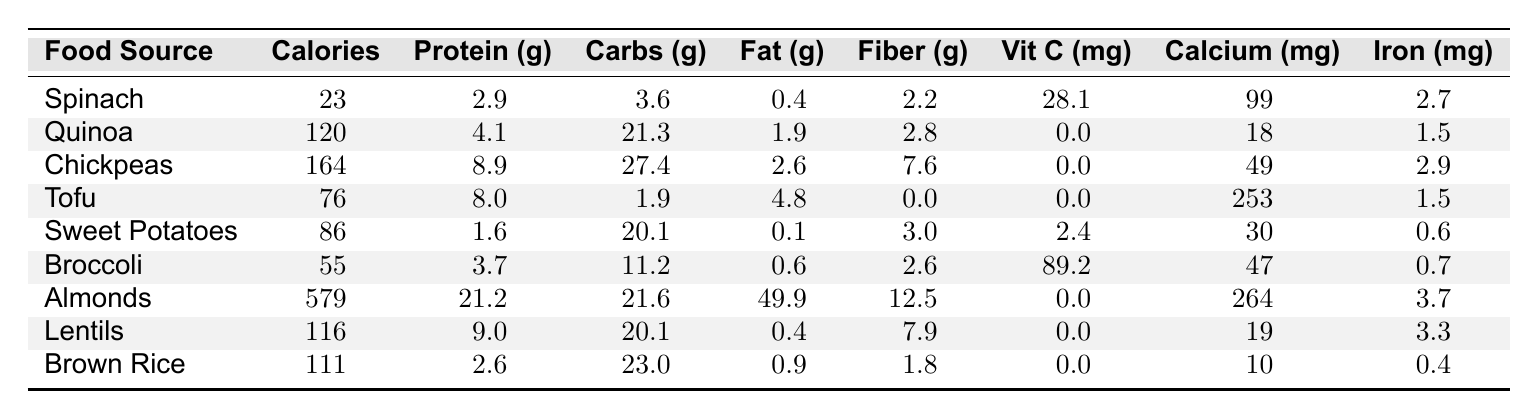What is the highest protein content food source among the listed options? By examining the table, we see that Almonds have the highest protein content at 21.2 grams.
Answer: 21.2 grams What is the total amount of calories in Spinach and Broccoli combined? Spinach has 23 calories and Broccoli has 55 calories. Adding them together gives: 23 + 55 = 78 calories.
Answer: 78 calories Which food source contains the most fiber? From the table, Almonds contain 12.5 grams of fiber, which is more than any other food source listed.
Answer: 12.5 grams Is Sweet Potatoes higher in potassium than Spinach? The table does not provide potassium values for either food source, so we cannot determine this based on the provided data.
Answer: Insufficient data How many grams of carbohydrates are there in Chickpeas? From the table, Chickpeas have 27.4 grams of carbohydrates.
Answer: 27.4 grams What is the average calcium content of the food sources listed? To find the average, sum the calcium values: 99 (Spinach) + 18 (Quinoa) + 49 (Chickpeas) + 253 (Tofu) + 30 (Sweet Potatoes) + 47 (Broccoli) + 264 (Almonds) + 19 (Lentils) + 10 (Brown Rice) = 799. There are 9 food sources, thus the average is 799/9 = 88.78 mg.
Answer: Approximately 88.8 mg Which food contains the least amount of fat? From the data, Sweet Potatoes have the least fat at 0.1 grams when compared to other foods listed.
Answer: 0.1 grams How does the iron content of Tofu compare to Chickpeas? Tofu has 1.5 mg of iron while Chickpeas contain 2.9 mg. Chickpeas have a higher iron content by 1.4 mg.
Answer: Chickpeas have more iron What is the difference in calorie content between Almonds and Lentils? Almonds have 579 calories and Lentils have 116 calories. The difference is 579 - 116 = 463 calories.
Answer: 463 calories Can you list the food sources that have a vitamin C content greater than 20 mg? The food sources with vitamin C above 20 mg are Spinach (28.1 mg) and Broccoli (89.2 mg).
Answer: Spinach and Broccoli 